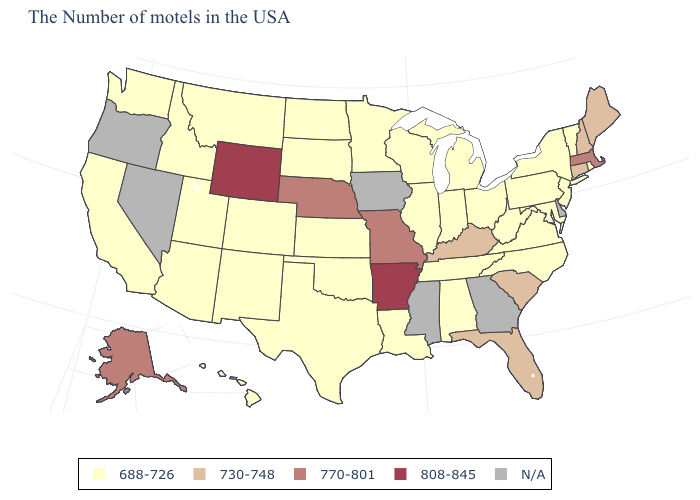Among the states that border Georgia , does North Carolina have the lowest value?
Concise answer only. Yes. Name the states that have a value in the range 730-748?
Be succinct. Maine, New Hampshire, Connecticut, South Carolina, Florida, Kentucky. What is the value of Alabama?
Keep it brief. 688-726. What is the lowest value in the South?
Be succinct. 688-726. Does the map have missing data?
Short answer required. Yes. Among the states that border Kentucky , does Missouri have the highest value?
Answer briefly. Yes. Does New York have the lowest value in the USA?
Answer briefly. Yes. How many symbols are there in the legend?
Give a very brief answer. 5. What is the lowest value in the USA?
Answer briefly. 688-726. Is the legend a continuous bar?
Short answer required. No. Does Arkansas have the highest value in the USA?
Answer briefly. Yes. How many symbols are there in the legend?
Write a very short answer. 5. Which states have the lowest value in the Northeast?
Short answer required. Rhode Island, Vermont, New York, New Jersey, Pennsylvania. 